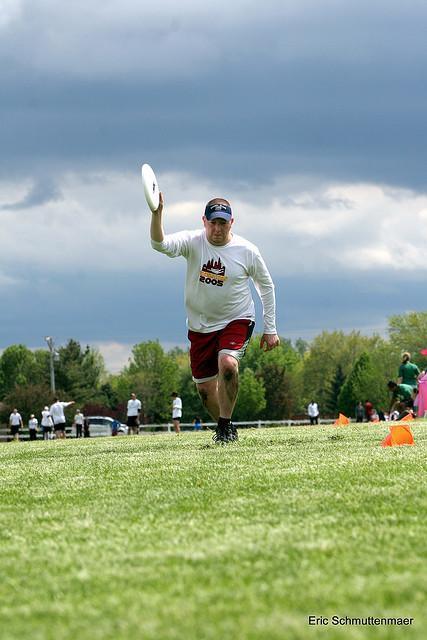How many chairs at the 3 tables?
Give a very brief answer. 0. 